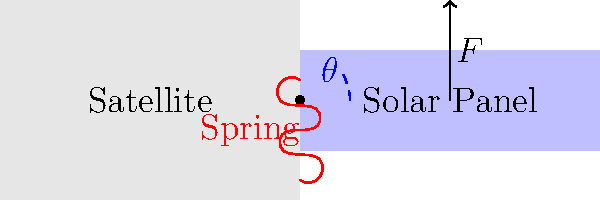Consider a satellite with a deployable solar panel as shown in the diagram. The panel is connected to the satellite body by a spring-loaded hinge mechanism. The deployment angle $\theta$ is measured from the stowed position. Given that the spring constant is $k = 2$ N/m, the panel mass is $m = 5$ kg, and the panel length is $L = 3$ m, calculate the minimum force $F$ required to hold the panel at a deployment angle of $30°$ in the absence of gravity. Assume the panel's center of mass is at its geometric center. To solve this problem, we'll follow these steps:

1) First, we need to determine the torque exerted by the spring. The spring torque is given by:

   $\tau_{spring} = k\theta$

   Where $k$ is the spring constant and $\theta$ is the angle in radians.

2) Convert the given angle to radians:

   $\theta = 30° \times \frac{\pi}{180°} = \frac{\pi}{6}$ radians

3) Calculate the spring torque:

   $\tau_{spring} = 2 \text{ N/m} \times \frac{\pi}{6} = \frac{\pi}{3}$ N⋅m

4) The force $F$ creates a counter-torque to balance the spring torque. This torque is given by:

   $\tau_{F} = F \times d$

   Where $d$ is the perpendicular distance from the line of action of $F$ to the hinge.

5) At $30°$, this distance is:

   $d = L \times \sin(30°) = 3 \text{ m} \times \frac{1}{2} = 1.5$ m

6) For equilibrium, the torques must be equal:

   $\tau_{spring} = \tau_{F}$
   $\frac{\pi}{3} = F \times 1.5$

7) Solve for $F$:

   $F = \frac{\pi}{3} \div 1.5 = \frac{\pi}{4.5}$ N

8) Calculate the numerical value:

   $F \approx 0.6981$ N

Therefore, the minimum force required to hold the panel at a $30°$ angle is approximately 0.6981 N.
Answer: 0.6981 N 